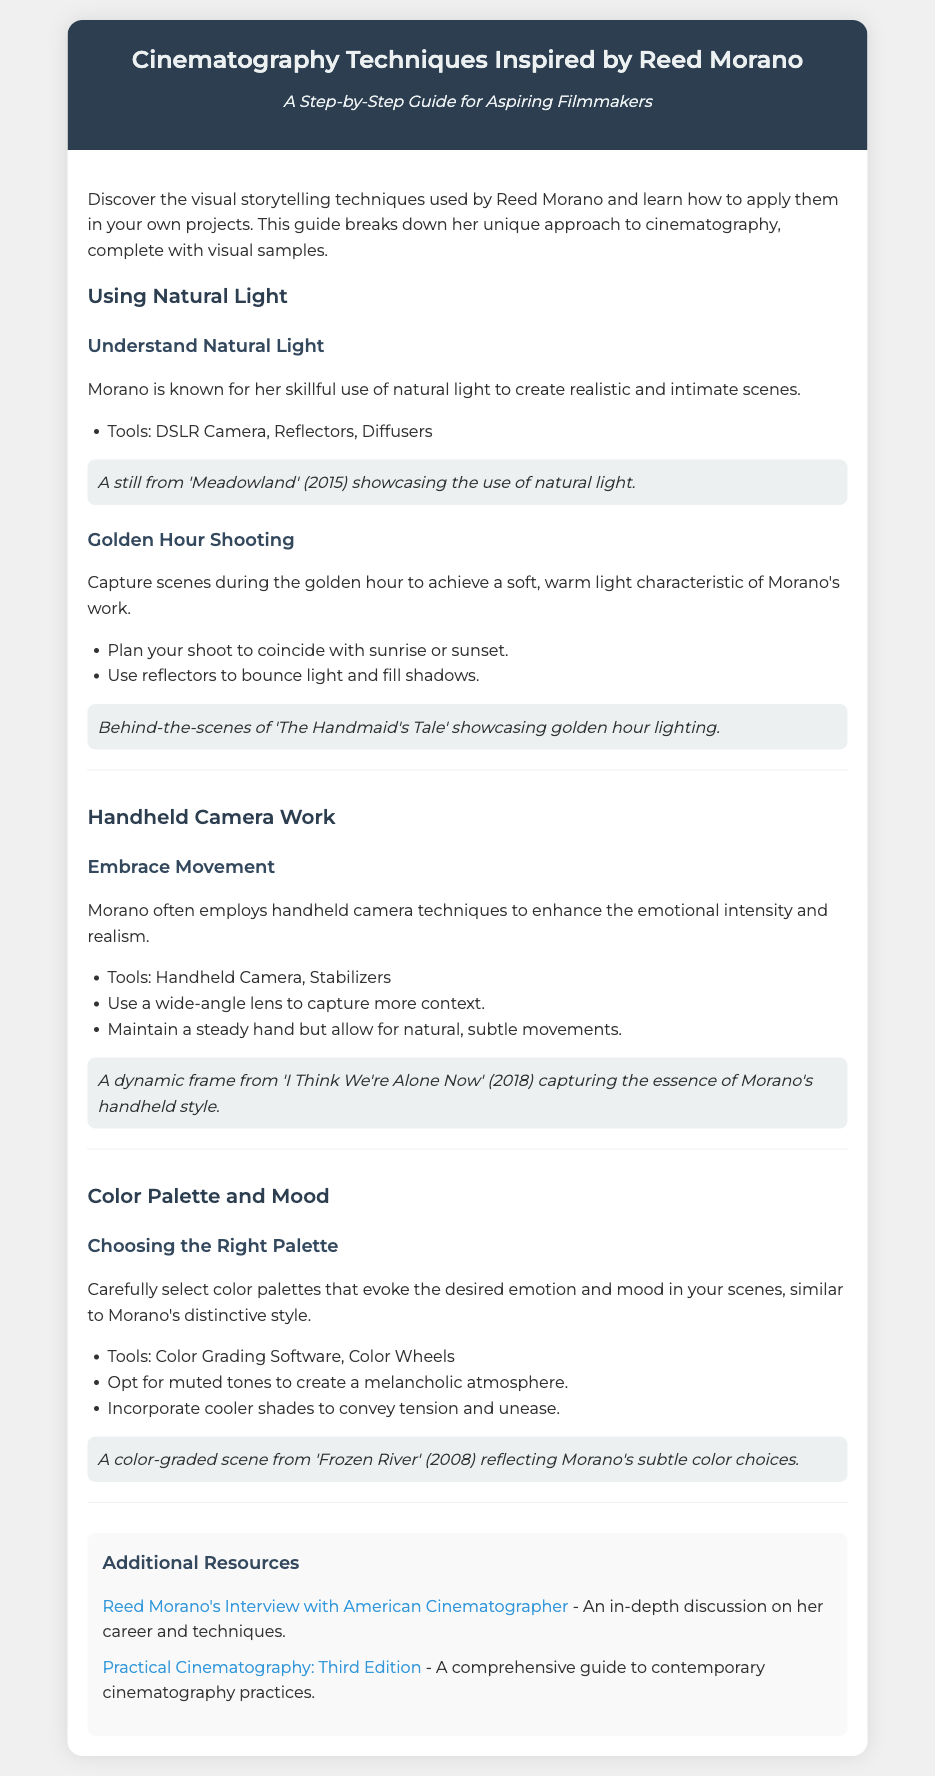what is the title of the document? The title is presented in the header section of the document and is "Cinematography Techniques Inspired by Reed Morano".
Answer: Cinematography Techniques Inspired by Reed Morano who is the main filmmaker discussed in the document? The document focuses on the cinematography techniques inspired by Reed Morano, which is stated in the header.
Answer: Reed Morano what is one tool recommended for using natural light? The document lists tools used for natural light techniques, such as "DSLR Camera".
Answer: DSLR Camera what shooting time is suggested to capture golden hour scenes? The document mentions planning shoots to coincide with sunrise or sunset for golden hour lighting.
Answer: sunrise or sunset which cinematography technique is highlighted for emotional intensity? The document discusses handheld camera work as a technique to enhance emotional intensity and realism.
Answer: handheld camera work what color grading tool is mentioned in the section about color palette? The document states that "Color Grading Software" is a tool for choosing the right color palette.
Answer: Color Grading Software how many visual samples are included in the document? The document shows visuals for each of the four sections covering techniques, indicating a total of four samples.
Answer: four what is one of the additional resources linked in the document? The document lists resources, including an interview with Reed Morano found at an American Cinematographer link.
Answer: Reed Morano's Interview with American Cinematographer what is the primary focus of the document? The introduction of the document describes it as a guide for aspiring filmmakers to learn techniques used by Morano.
Answer: techniques used by Reed Morano 